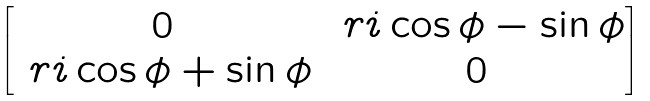Convert formula to latex. <formula><loc_0><loc_0><loc_500><loc_500>\begin{bmatrix} 0 & \ r i \cos \phi - \sin \phi \\ \ r i \cos \phi + \sin \phi & 0 \end{bmatrix}</formula> 